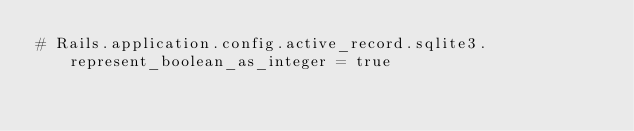Convert code to text. <code><loc_0><loc_0><loc_500><loc_500><_Ruby_># Rails.application.config.active_record.sqlite3.represent_boolean_as_integer = true
</code> 